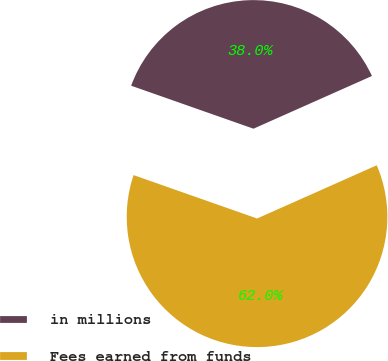Convert chart to OTSL. <chart><loc_0><loc_0><loc_500><loc_500><pie_chart><fcel>in millions<fcel>Fees earned from funds<nl><fcel>37.96%<fcel>62.04%<nl></chart> 